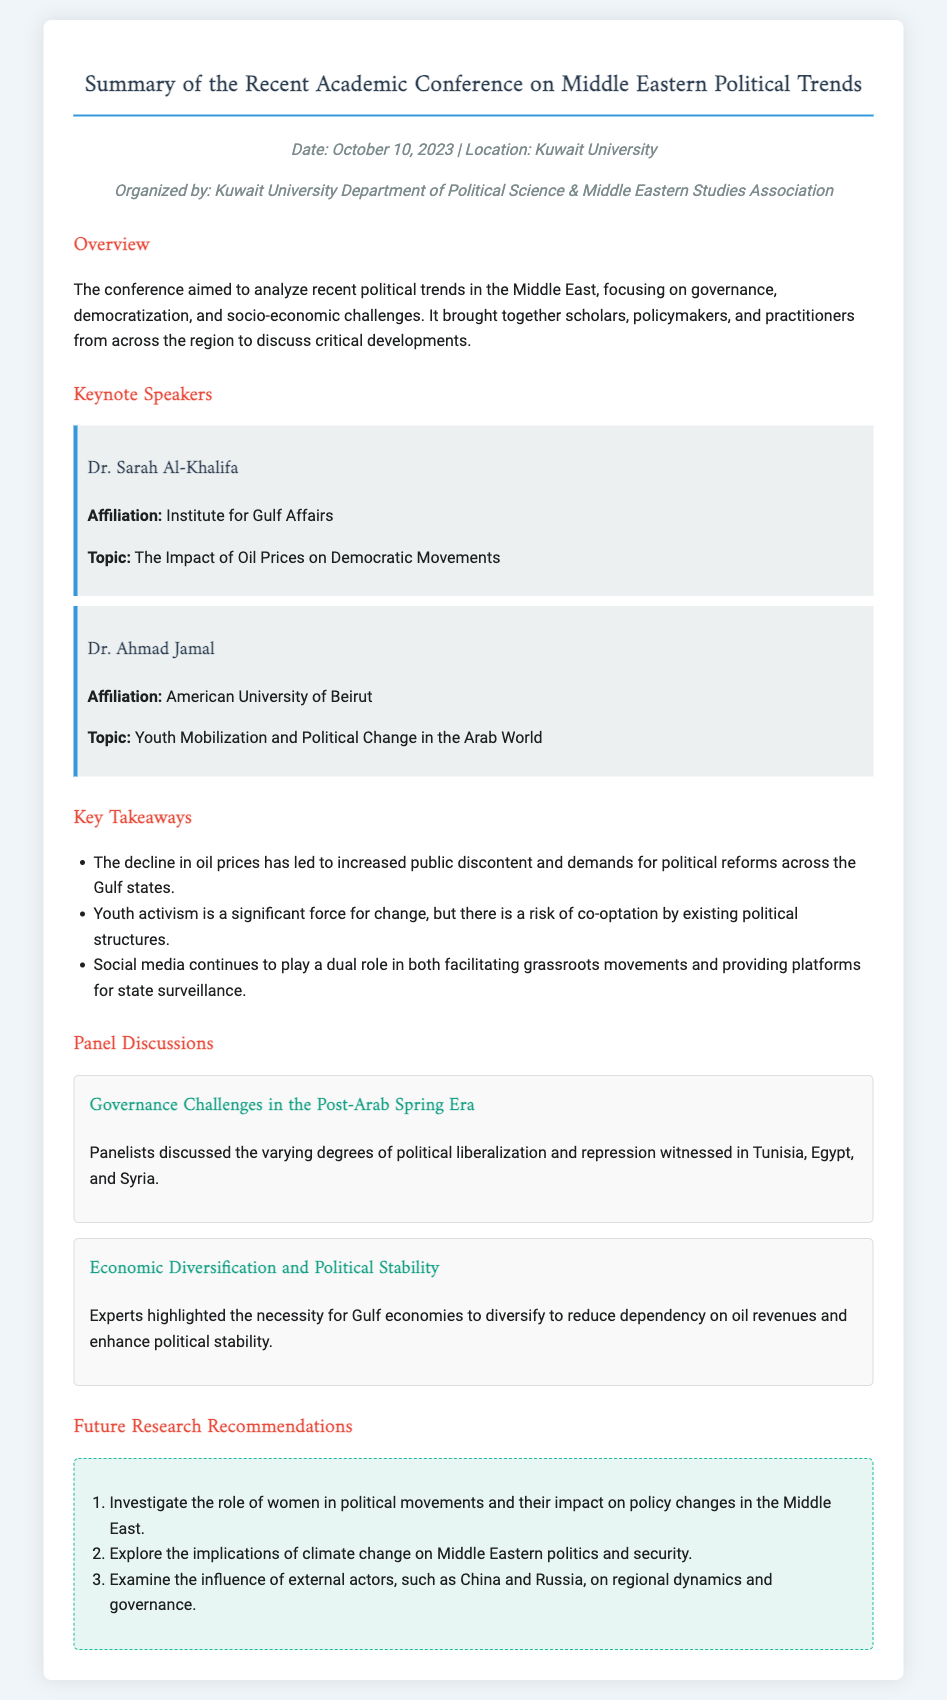What was the date of the conference? The date is explicitly mentioned in the document under the meta-info section.
Answer: October 10, 2023 What is the topic of Dr. Ahmad Jamal's keynote speech? The topic of the keynote speech is listed under Dr. Ahmad Jamal's section.
Answer: Youth Mobilization and Political Change in the Arab World Which organization organized the conference? The organizing body is stated in the meta-info section of the document.
Answer: Kuwait University Department of Political Science & Middle Eastern Studies Association What is one key takeaway regarding youth activism? The key takeaway is summarized in the "Key Takeaways" section of the document.
Answer: There is a risk of co-optation by existing political structures What is one recommendation for future research? Future research recommendations are outlined in the recommendations section of the document.
Answer: Investigate the role of women in political movements and their impact on policy changes in the Middle East 